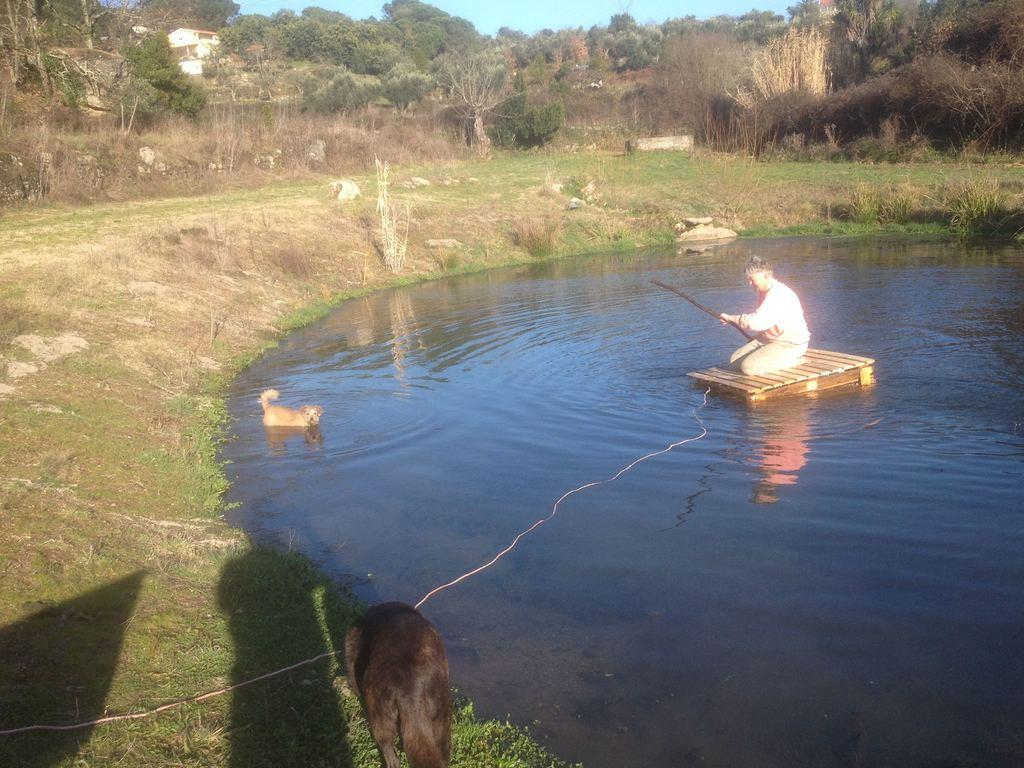What is the person in the image doing? The person is holding a fishing rod. Where is the person sitting in the image? The person is sitting on a platform. How many dogs are in the image? There are two dogs in the image. What is the position of one of the dogs in the image? One dog is in the water. What type of vegetation is present in the image? Grass is present in the image. What type of natural environment is visible in the image? Trees are visible in the image. What is visible in the background of the image? The sky is visible in the background of the image. What type of train can be seen in the image? There is no train present in the image. What kind of trouble is the person experiencing while fishing in the image? The image does not depict any trouble or difficulties for the person while fishing. 